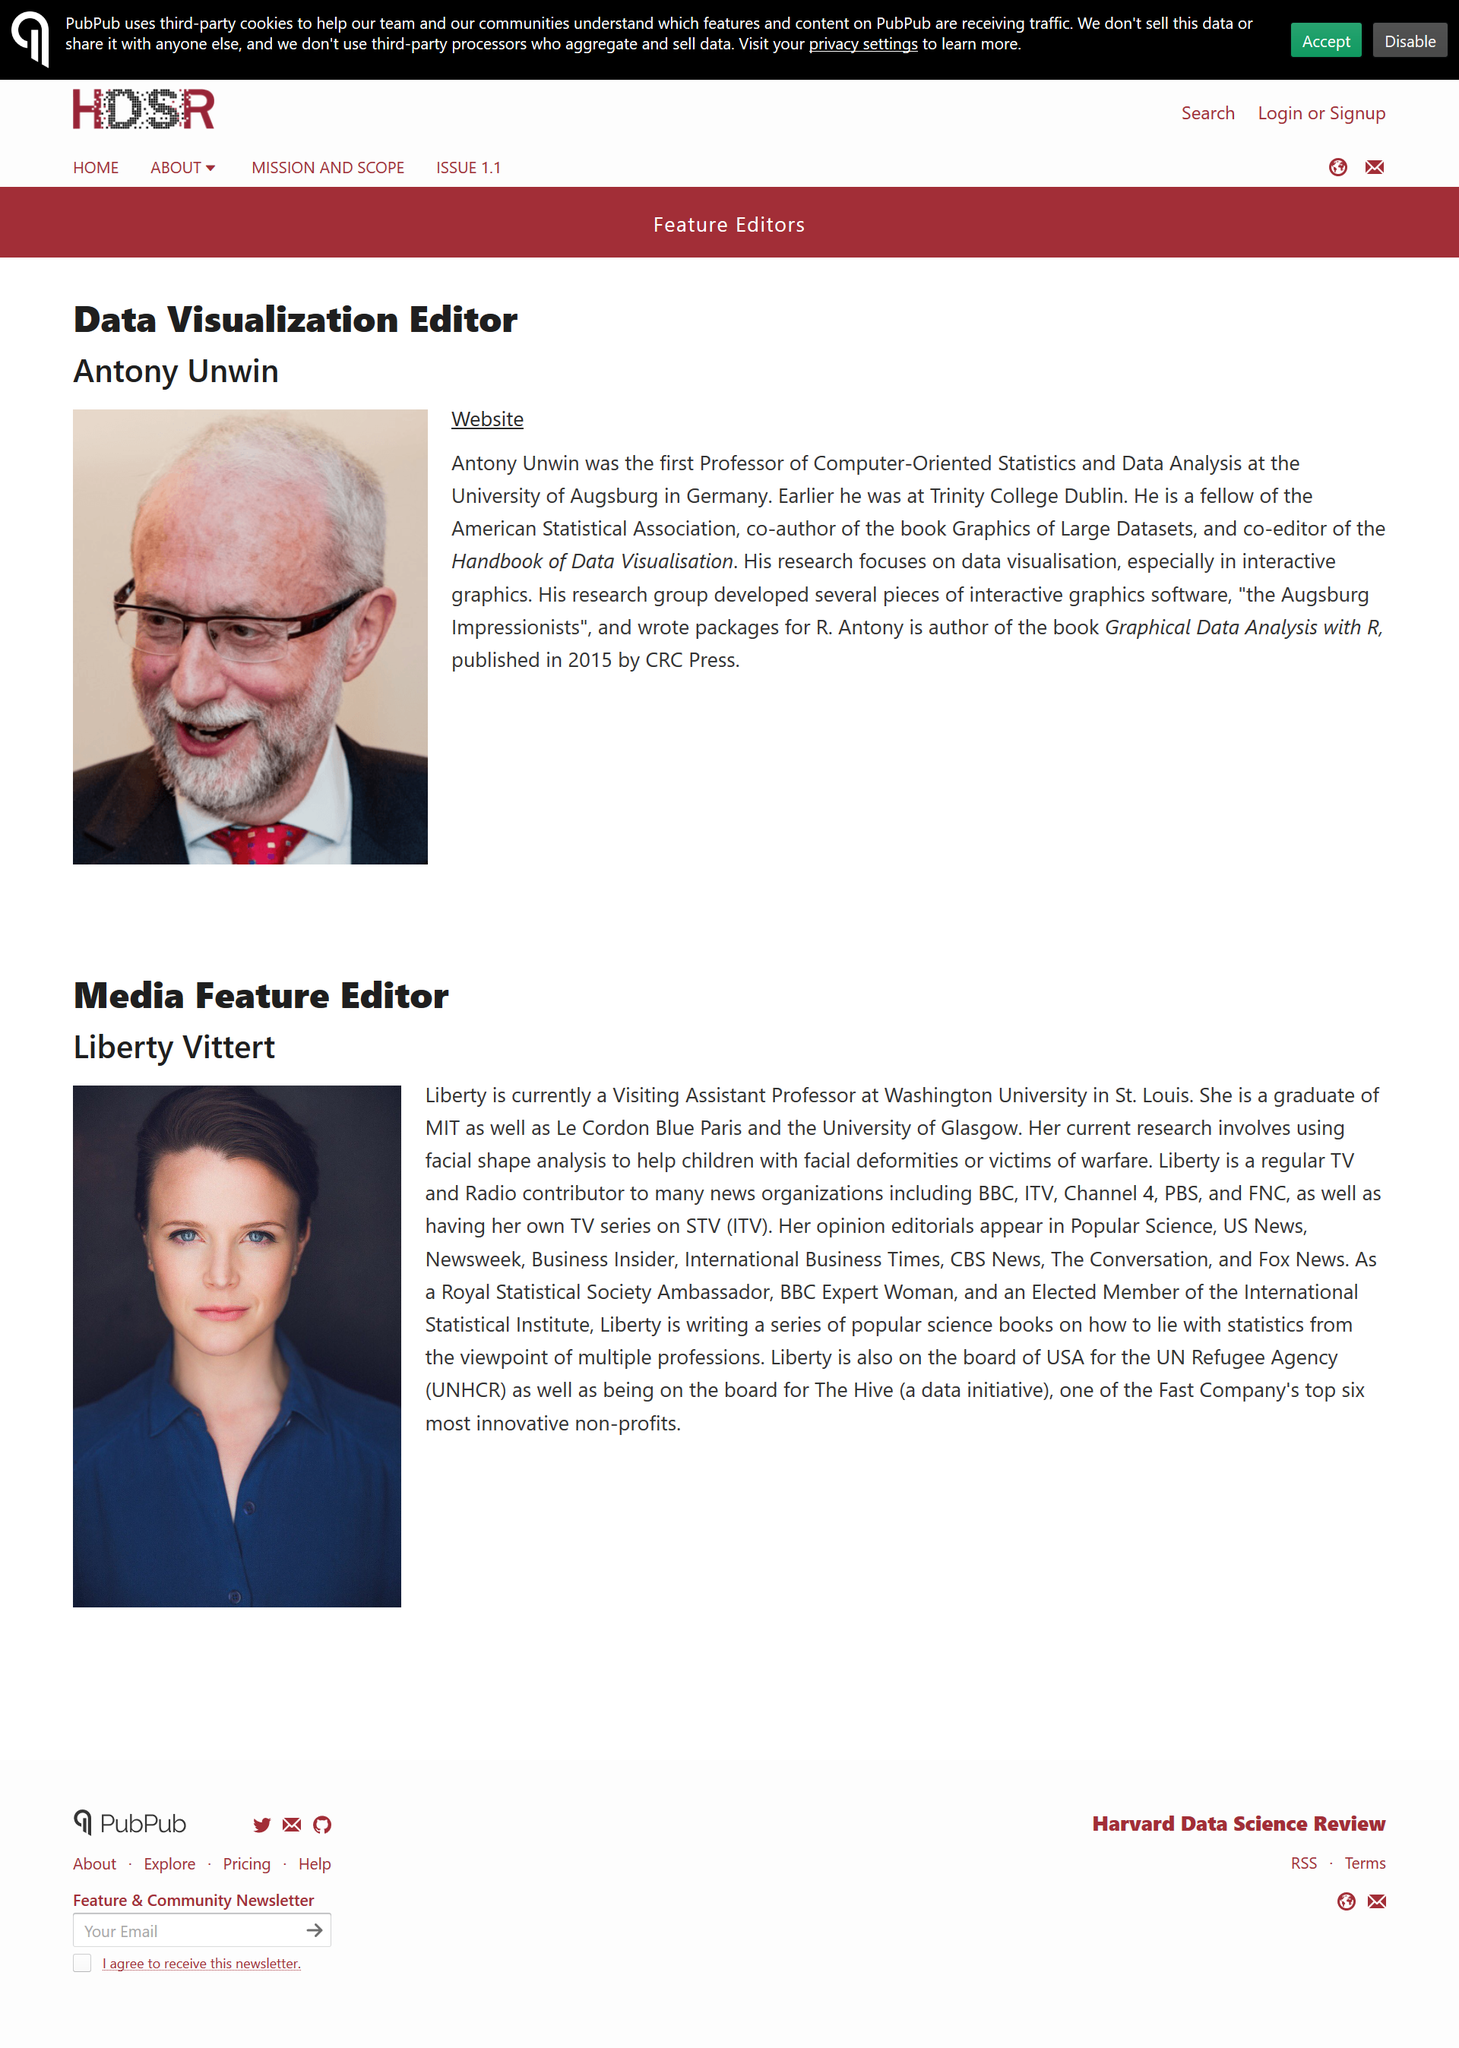Specify some key components in this picture. Antony Unwin is the Data Visualization Editor, responsible for overseeing the creation of informative and visually appealing graphics used in the journal. The question asks whether a picture of the person is featured on the page (Yes/No), with the answer being "Yes. The individual currently holds the position of Visiting Assistant Professor. Antony Unwin's research focuses on data visualization. Antony was the first Professor of Computer-Oriented Statistics and Data Analysis at the University of Augsburg. 